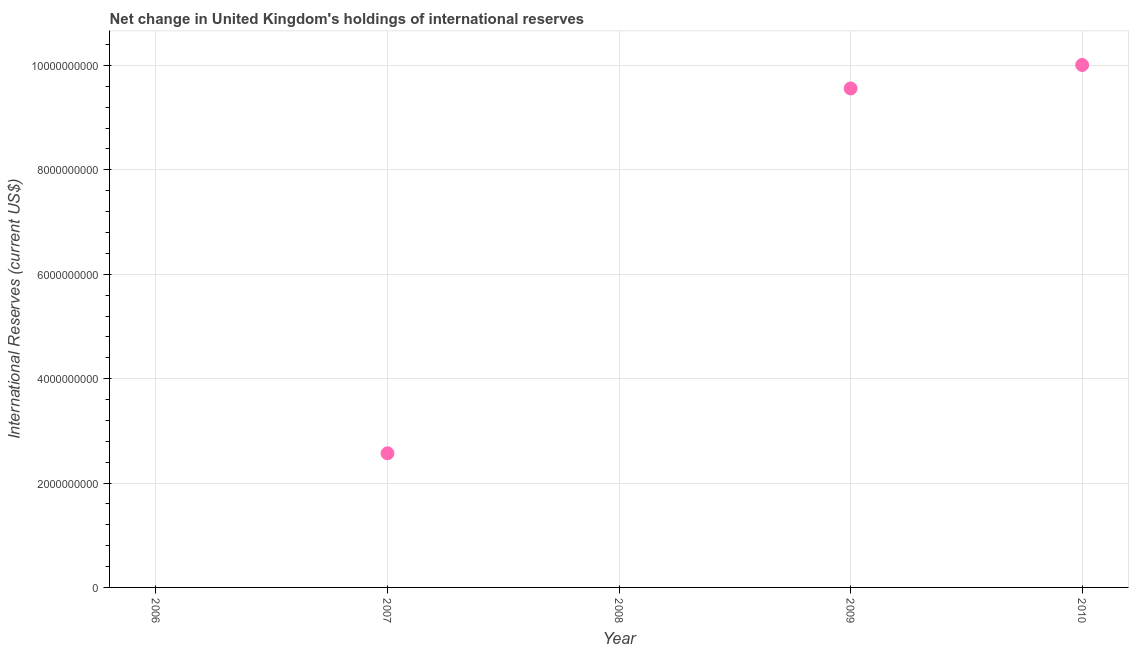Across all years, what is the maximum reserves and related items?
Give a very brief answer. 1.00e+1. What is the sum of the reserves and related items?
Your response must be concise. 2.21e+1. What is the difference between the reserves and related items in 2007 and 2010?
Offer a very short reply. -7.44e+09. What is the average reserves and related items per year?
Give a very brief answer. 4.43e+09. What is the median reserves and related items?
Your response must be concise. 2.57e+09. In how many years, is the reserves and related items greater than 1600000000 US$?
Make the answer very short. 3. What is the ratio of the reserves and related items in 2007 to that in 2010?
Make the answer very short. 0.26. Is the difference between the reserves and related items in 2007 and 2010 greater than the difference between any two years?
Offer a terse response. No. What is the difference between the highest and the second highest reserves and related items?
Make the answer very short. 4.50e+08. Is the sum of the reserves and related items in 2009 and 2010 greater than the maximum reserves and related items across all years?
Ensure brevity in your answer.  Yes. What is the difference between the highest and the lowest reserves and related items?
Keep it short and to the point. 1.00e+1. In how many years, is the reserves and related items greater than the average reserves and related items taken over all years?
Make the answer very short. 2. Are the values on the major ticks of Y-axis written in scientific E-notation?
Give a very brief answer. No. What is the title of the graph?
Provide a succinct answer. Net change in United Kingdom's holdings of international reserves. What is the label or title of the X-axis?
Your answer should be compact. Year. What is the label or title of the Y-axis?
Offer a very short reply. International Reserves (current US$). What is the International Reserves (current US$) in 2006?
Ensure brevity in your answer.  0. What is the International Reserves (current US$) in 2007?
Make the answer very short. 2.57e+09. What is the International Reserves (current US$) in 2009?
Give a very brief answer. 9.56e+09. What is the International Reserves (current US$) in 2010?
Provide a succinct answer. 1.00e+1. What is the difference between the International Reserves (current US$) in 2007 and 2009?
Give a very brief answer. -6.99e+09. What is the difference between the International Reserves (current US$) in 2007 and 2010?
Offer a terse response. -7.44e+09. What is the difference between the International Reserves (current US$) in 2009 and 2010?
Provide a short and direct response. -4.50e+08. What is the ratio of the International Reserves (current US$) in 2007 to that in 2009?
Give a very brief answer. 0.27. What is the ratio of the International Reserves (current US$) in 2007 to that in 2010?
Your answer should be compact. 0.26. What is the ratio of the International Reserves (current US$) in 2009 to that in 2010?
Provide a short and direct response. 0.95. 